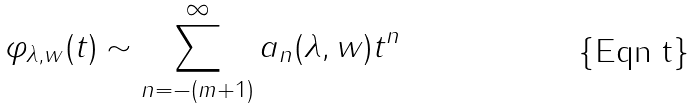<formula> <loc_0><loc_0><loc_500><loc_500>\varphi _ { \lambda , w } ( t ) \sim \sum _ { n = - ( m + 1 ) } ^ { \infty } a _ { n } ( \lambda , w ) t ^ { n }</formula> 